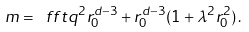<formula> <loc_0><loc_0><loc_500><loc_500>m = \ f f t { q ^ { 2 } } { r _ { 0 } ^ { d - 3 } } + r _ { 0 } ^ { d - 3 } ( 1 + \lambda ^ { 2 } r _ { 0 } ^ { 2 } ) \, .</formula> 